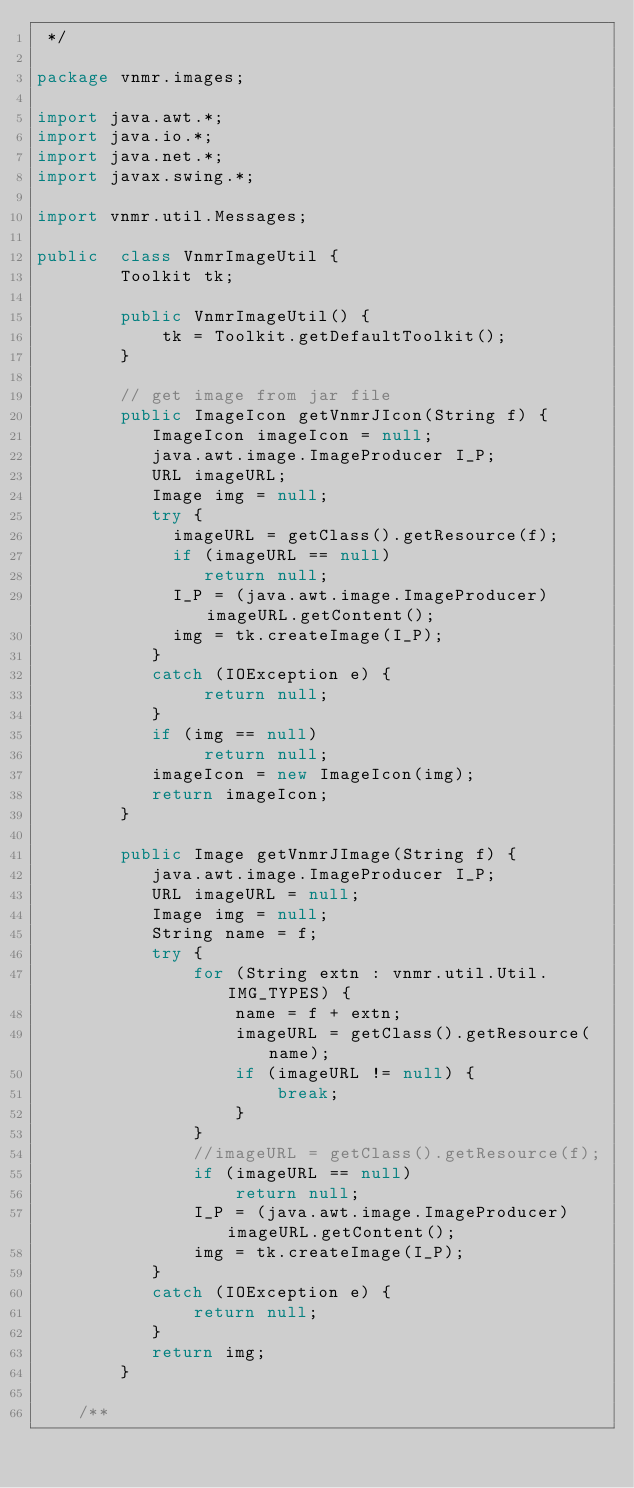Convert code to text. <code><loc_0><loc_0><loc_500><loc_500><_Java_> */

package vnmr.images;

import java.awt.*;
import java.io.*;
import java.net.*;
import javax.swing.*;

import vnmr.util.Messages;

public  class VnmrImageUtil {
        Toolkit tk;

        public VnmrImageUtil() {
            tk = Toolkit.getDefaultToolkit();
        }

        // get image from jar file 
        public ImageIcon getVnmrJIcon(String f) {
           ImageIcon imageIcon = null;
           java.awt.image.ImageProducer I_P;
           URL imageURL;
           Image img = null;
           try {
             imageURL = getClass().getResource(f);
             if (imageURL == null)
                return null; 
             I_P = (java.awt.image.ImageProducer)imageURL.getContent();
             img = tk.createImage(I_P);
           }
           catch (IOException e) {
                return null; 
           }
           if (img == null)
                return null; 
           imageIcon = new ImageIcon(img);
           return imageIcon;
        }

        public Image getVnmrJImage(String f) {
           java.awt.image.ImageProducer I_P;
           URL imageURL = null;
           Image img = null;
           String name = f;
           try {
               for (String extn : vnmr.util.Util.IMG_TYPES) {
                   name = f + extn;
                   imageURL = getClass().getResource(name);
                   if (imageURL != null) {
                       break;
                   }
               }
               //imageURL = getClass().getResource(f);
               if (imageURL == null)
                   return null; 
               I_P = (java.awt.image.ImageProducer)imageURL.getContent();
               img = tk.createImage(I_P);
           }
           catch (IOException e) {
               return null;
           }
           return img;
        }

    /**</code> 